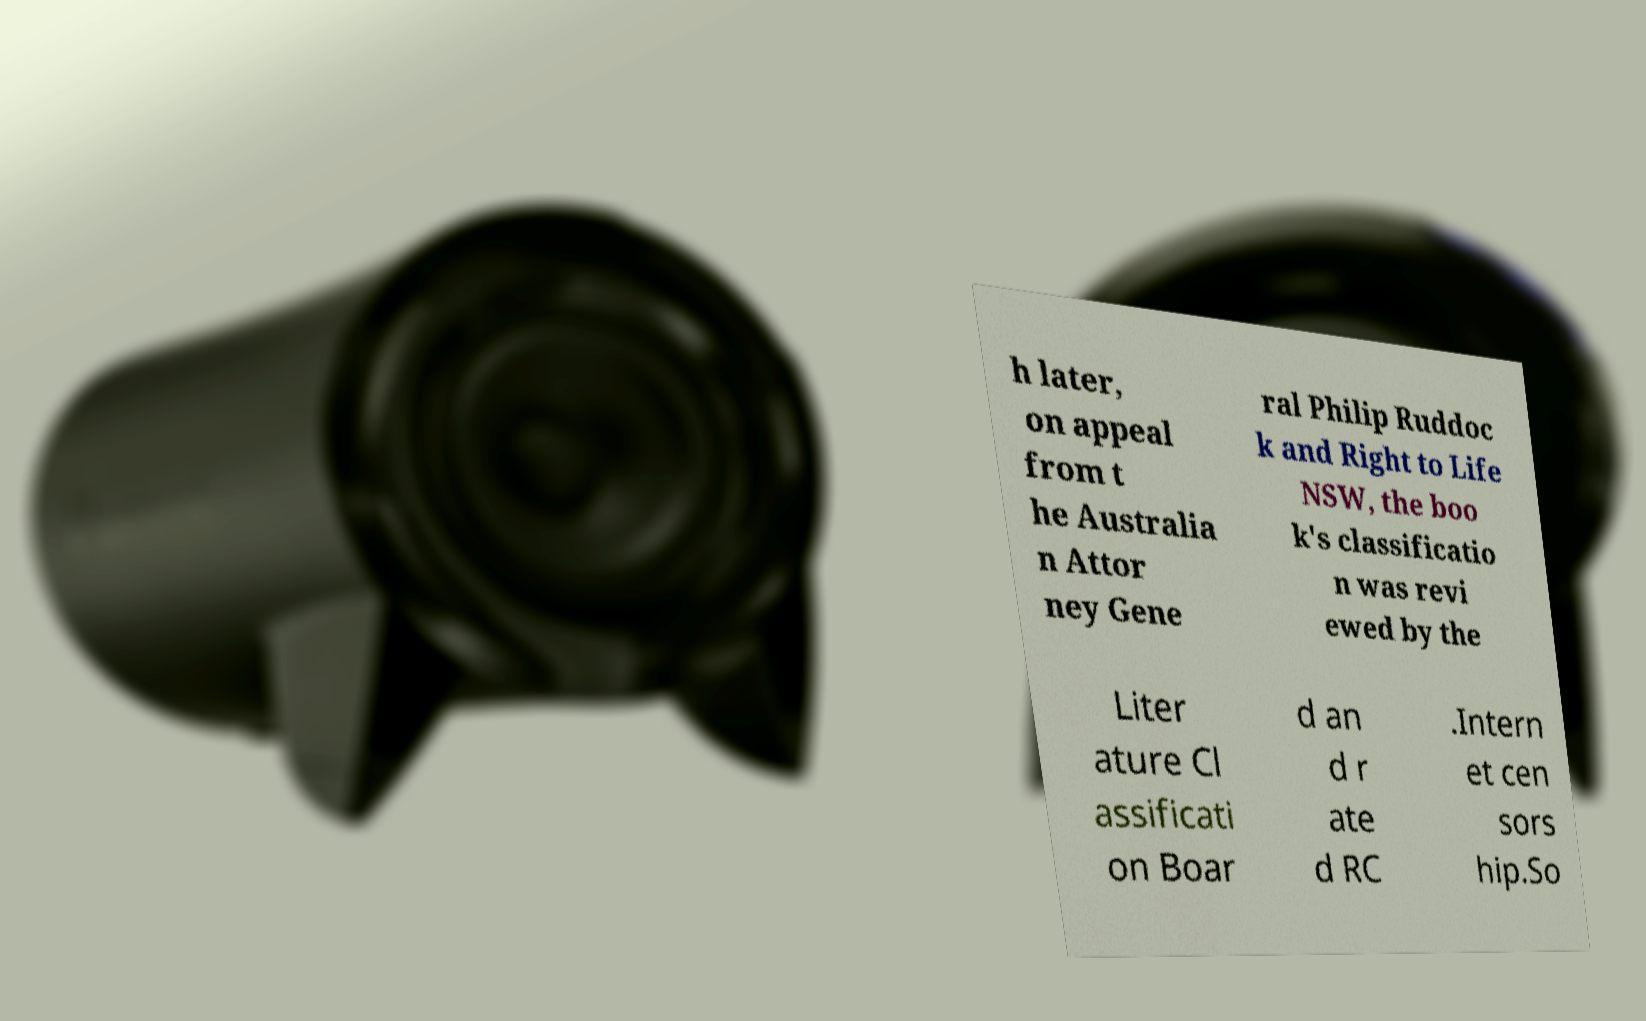Please read and relay the text visible in this image. What does it say? h later, on appeal from t he Australia n Attor ney Gene ral Philip Ruddoc k and Right to Life NSW, the boo k's classificatio n was revi ewed by the Liter ature Cl assificati on Boar d an d r ate d RC .Intern et cen sors hip.So 